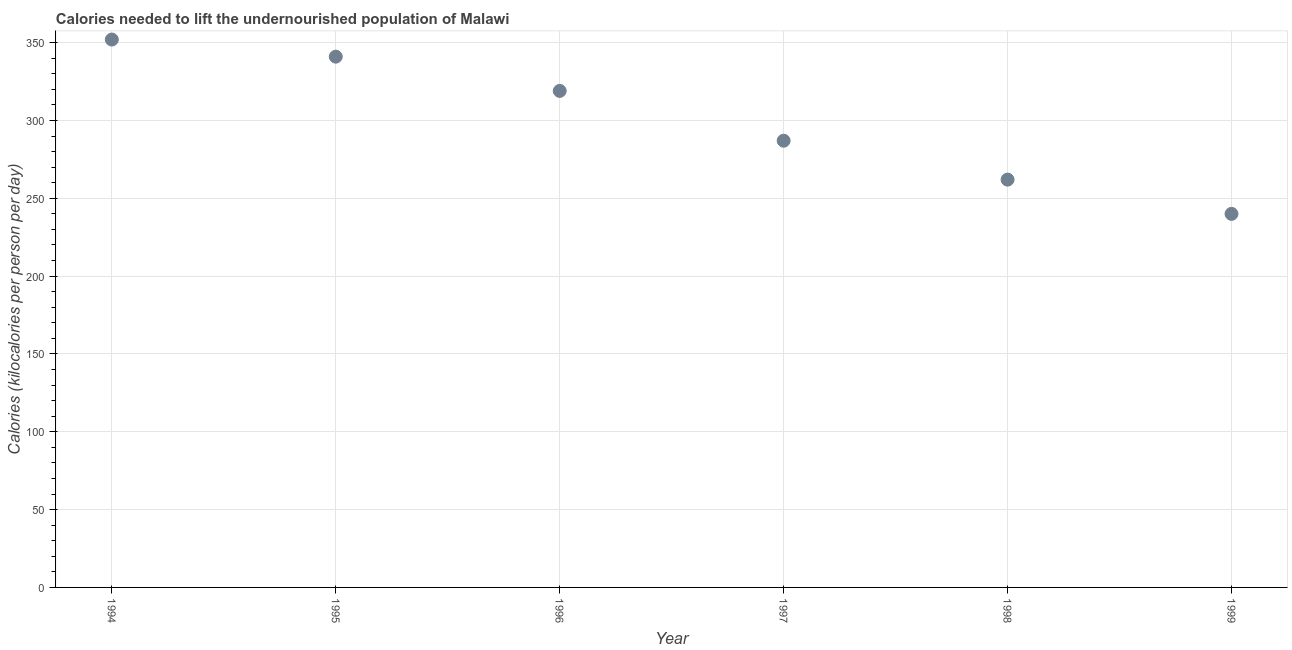What is the depth of food deficit in 1997?
Your answer should be compact. 287. Across all years, what is the maximum depth of food deficit?
Keep it short and to the point. 352. Across all years, what is the minimum depth of food deficit?
Give a very brief answer. 240. What is the sum of the depth of food deficit?
Ensure brevity in your answer.  1801. What is the difference between the depth of food deficit in 1994 and 1999?
Your answer should be very brief. 112. What is the average depth of food deficit per year?
Make the answer very short. 300.17. What is the median depth of food deficit?
Provide a succinct answer. 303. What is the ratio of the depth of food deficit in 1994 to that in 1997?
Your answer should be compact. 1.23. What is the difference between the highest and the second highest depth of food deficit?
Ensure brevity in your answer.  11. Is the sum of the depth of food deficit in 1995 and 1997 greater than the maximum depth of food deficit across all years?
Make the answer very short. Yes. What is the difference between the highest and the lowest depth of food deficit?
Your answer should be very brief. 112. Does the depth of food deficit monotonically increase over the years?
Your answer should be compact. No. How many dotlines are there?
Provide a short and direct response. 1. Are the values on the major ticks of Y-axis written in scientific E-notation?
Provide a succinct answer. No. Does the graph contain grids?
Your answer should be very brief. Yes. What is the title of the graph?
Provide a short and direct response. Calories needed to lift the undernourished population of Malawi. What is the label or title of the Y-axis?
Your response must be concise. Calories (kilocalories per person per day). What is the Calories (kilocalories per person per day) in 1994?
Offer a terse response. 352. What is the Calories (kilocalories per person per day) in 1995?
Provide a short and direct response. 341. What is the Calories (kilocalories per person per day) in 1996?
Offer a terse response. 319. What is the Calories (kilocalories per person per day) in 1997?
Give a very brief answer. 287. What is the Calories (kilocalories per person per day) in 1998?
Make the answer very short. 262. What is the Calories (kilocalories per person per day) in 1999?
Provide a short and direct response. 240. What is the difference between the Calories (kilocalories per person per day) in 1994 and 1997?
Make the answer very short. 65. What is the difference between the Calories (kilocalories per person per day) in 1994 and 1998?
Give a very brief answer. 90. What is the difference between the Calories (kilocalories per person per day) in 1994 and 1999?
Provide a succinct answer. 112. What is the difference between the Calories (kilocalories per person per day) in 1995 and 1996?
Offer a terse response. 22. What is the difference between the Calories (kilocalories per person per day) in 1995 and 1998?
Make the answer very short. 79. What is the difference between the Calories (kilocalories per person per day) in 1995 and 1999?
Offer a terse response. 101. What is the difference between the Calories (kilocalories per person per day) in 1996 and 1998?
Ensure brevity in your answer.  57. What is the difference between the Calories (kilocalories per person per day) in 1996 and 1999?
Provide a short and direct response. 79. What is the difference between the Calories (kilocalories per person per day) in 1998 and 1999?
Your answer should be compact. 22. What is the ratio of the Calories (kilocalories per person per day) in 1994 to that in 1995?
Your answer should be compact. 1.03. What is the ratio of the Calories (kilocalories per person per day) in 1994 to that in 1996?
Your answer should be compact. 1.1. What is the ratio of the Calories (kilocalories per person per day) in 1994 to that in 1997?
Keep it short and to the point. 1.23. What is the ratio of the Calories (kilocalories per person per day) in 1994 to that in 1998?
Offer a terse response. 1.34. What is the ratio of the Calories (kilocalories per person per day) in 1994 to that in 1999?
Make the answer very short. 1.47. What is the ratio of the Calories (kilocalories per person per day) in 1995 to that in 1996?
Make the answer very short. 1.07. What is the ratio of the Calories (kilocalories per person per day) in 1995 to that in 1997?
Keep it short and to the point. 1.19. What is the ratio of the Calories (kilocalories per person per day) in 1995 to that in 1998?
Make the answer very short. 1.3. What is the ratio of the Calories (kilocalories per person per day) in 1995 to that in 1999?
Keep it short and to the point. 1.42. What is the ratio of the Calories (kilocalories per person per day) in 1996 to that in 1997?
Offer a terse response. 1.11. What is the ratio of the Calories (kilocalories per person per day) in 1996 to that in 1998?
Ensure brevity in your answer.  1.22. What is the ratio of the Calories (kilocalories per person per day) in 1996 to that in 1999?
Ensure brevity in your answer.  1.33. What is the ratio of the Calories (kilocalories per person per day) in 1997 to that in 1998?
Provide a short and direct response. 1.09. What is the ratio of the Calories (kilocalories per person per day) in 1997 to that in 1999?
Give a very brief answer. 1.2. What is the ratio of the Calories (kilocalories per person per day) in 1998 to that in 1999?
Make the answer very short. 1.09. 